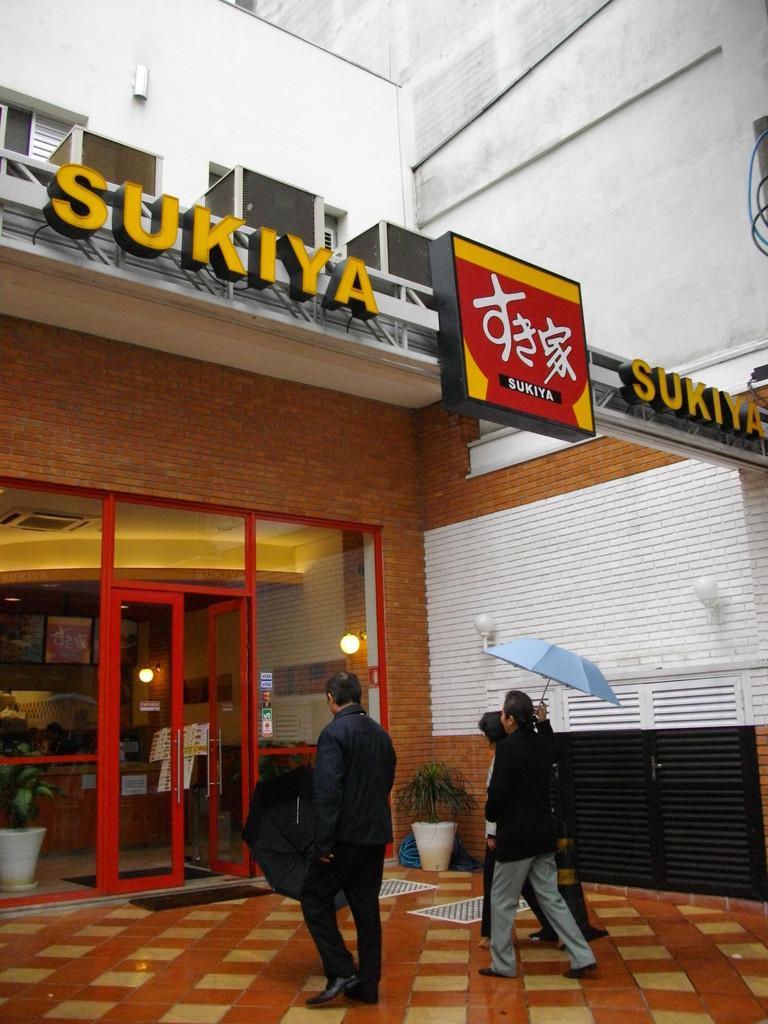In one or two sentences, can you explain what this image depicts? This image consists of three persons walking and holding the umbrellas. At the bottom, there is a floor. In the front, it looks like a restaurant. And we can see a door in red color. At the top, there is a name board. On the right, there is a building. 